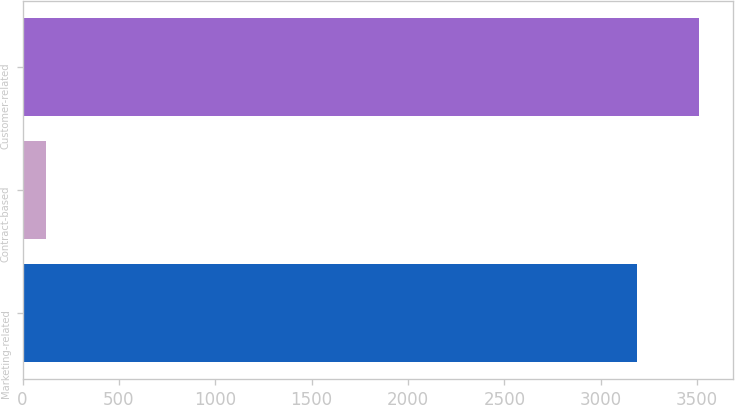Convert chart. <chart><loc_0><loc_0><loc_500><loc_500><bar_chart><fcel>Marketing-related<fcel>Contract-based<fcel>Customer-related<nl><fcel>3187<fcel>119<fcel>3510.4<nl></chart> 